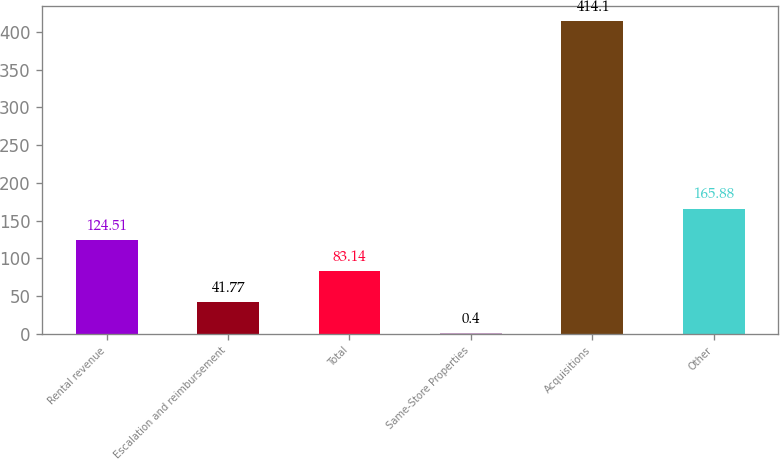Convert chart. <chart><loc_0><loc_0><loc_500><loc_500><bar_chart><fcel>Rental revenue<fcel>Escalation and reimbursement<fcel>Total<fcel>Same-Store Properties<fcel>Acquisitions<fcel>Other<nl><fcel>124.51<fcel>41.77<fcel>83.14<fcel>0.4<fcel>414.1<fcel>165.88<nl></chart> 